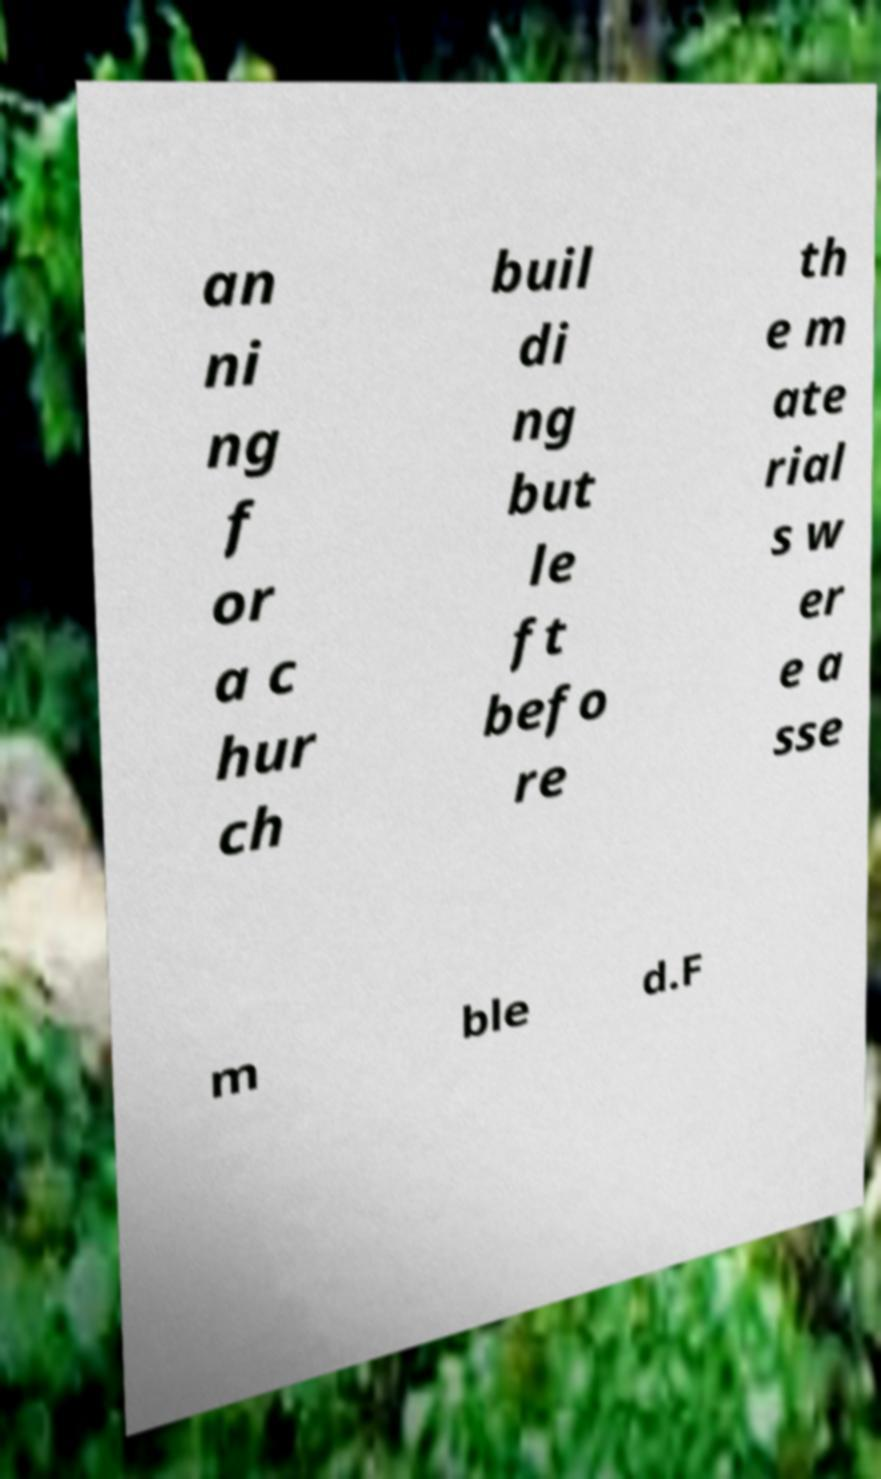There's text embedded in this image that I need extracted. Can you transcribe it verbatim? an ni ng f or a c hur ch buil di ng but le ft befo re th e m ate rial s w er e a sse m ble d.F 